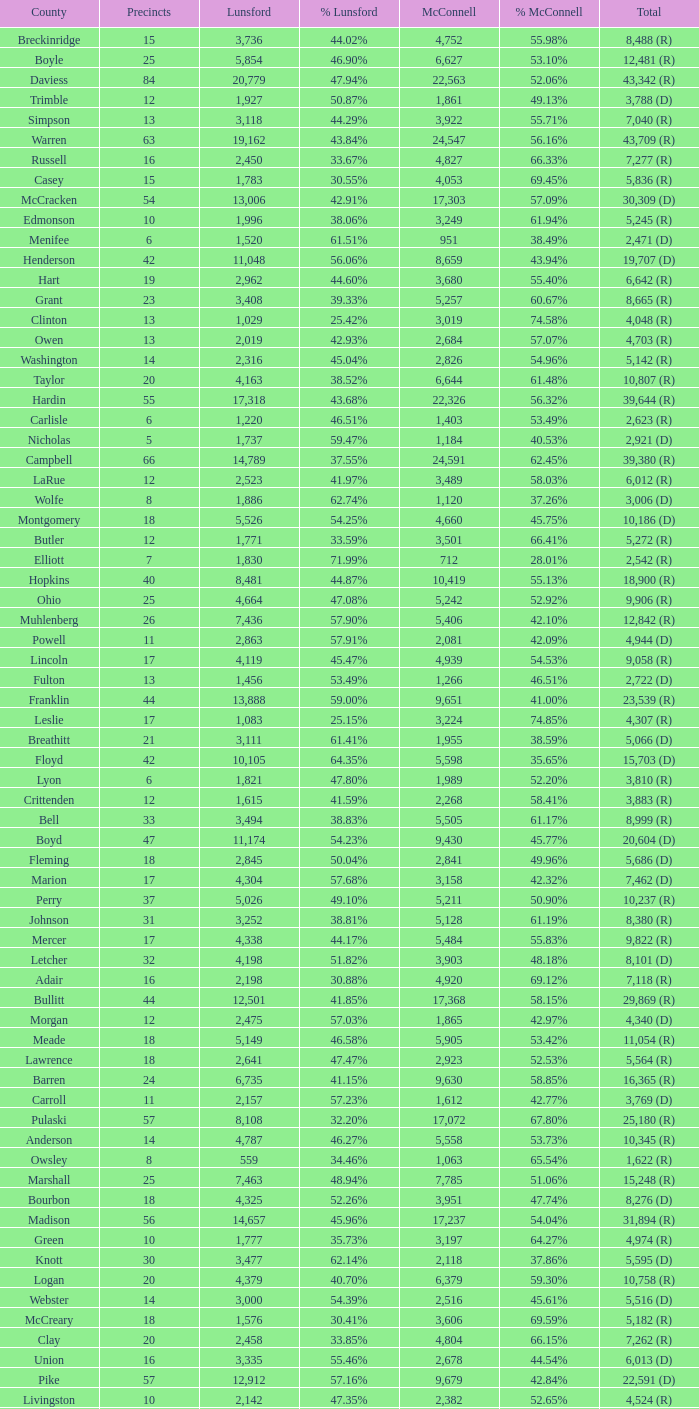What is the total number of Lunsford votes when the percentage of those votes is 33.85%? 1.0. Would you be able to parse every entry in this table? {'header': ['County', 'Precincts', 'Lunsford', '% Lunsford', 'McConnell', '% McConnell', 'Total'], 'rows': [['Breckinridge', '15', '3,736', '44.02%', '4,752', '55.98%', '8,488 (R)'], ['Boyle', '25', '5,854', '46.90%', '6,627', '53.10%', '12,481 (R)'], ['Daviess', '84', '20,779', '47.94%', '22,563', '52.06%', '43,342 (R)'], ['Trimble', '12', '1,927', '50.87%', '1,861', '49.13%', '3,788 (D)'], ['Simpson', '13', '3,118', '44.29%', '3,922', '55.71%', '7,040 (R)'], ['Warren', '63', '19,162', '43.84%', '24,547', '56.16%', '43,709 (R)'], ['Russell', '16', '2,450', '33.67%', '4,827', '66.33%', '7,277 (R)'], ['Casey', '15', '1,783', '30.55%', '4,053', '69.45%', '5,836 (R)'], ['McCracken', '54', '13,006', '42.91%', '17,303', '57.09%', '30,309 (D)'], ['Edmonson', '10', '1,996', '38.06%', '3,249', '61.94%', '5,245 (R)'], ['Menifee', '6', '1,520', '61.51%', '951', '38.49%', '2,471 (D)'], ['Henderson', '42', '11,048', '56.06%', '8,659', '43.94%', '19,707 (D)'], ['Hart', '19', '2,962', '44.60%', '3,680', '55.40%', '6,642 (R)'], ['Grant', '23', '3,408', '39.33%', '5,257', '60.67%', '8,665 (R)'], ['Clinton', '13', '1,029', '25.42%', '3,019', '74.58%', '4,048 (R)'], ['Owen', '13', '2,019', '42.93%', '2,684', '57.07%', '4,703 (R)'], ['Washington', '14', '2,316', '45.04%', '2,826', '54.96%', '5,142 (R)'], ['Taylor', '20', '4,163', '38.52%', '6,644', '61.48%', '10,807 (R)'], ['Hardin', '55', '17,318', '43.68%', '22,326', '56.32%', '39,644 (R)'], ['Carlisle', '6', '1,220', '46.51%', '1,403', '53.49%', '2,623 (R)'], ['Nicholas', '5', '1,737', '59.47%', '1,184', '40.53%', '2,921 (D)'], ['Campbell', '66', '14,789', '37.55%', '24,591', '62.45%', '39,380 (R)'], ['LaRue', '12', '2,523', '41.97%', '3,489', '58.03%', '6,012 (R)'], ['Wolfe', '8', '1,886', '62.74%', '1,120', '37.26%', '3,006 (D)'], ['Montgomery', '18', '5,526', '54.25%', '4,660', '45.75%', '10,186 (D)'], ['Butler', '12', '1,771', '33.59%', '3,501', '66.41%', '5,272 (R)'], ['Elliott', '7', '1,830', '71.99%', '712', '28.01%', '2,542 (R)'], ['Hopkins', '40', '8,481', '44.87%', '10,419', '55.13%', '18,900 (R)'], ['Ohio', '25', '4,664', '47.08%', '5,242', '52.92%', '9,906 (R)'], ['Muhlenberg', '26', '7,436', '57.90%', '5,406', '42.10%', '12,842 (R)'], ['Powell', '11', '2,863', '57.91%', '2,081', '42.09%', '4,944 (D)'], ['Lincoln', '17', '4,119', '45.47%', '4,939', '54.53%', '9,058 (R)'], ['Fulton', '13', '1,456', '53.49%', '1,266', '46.51%', '2,722 (D)'], ['Franklin', '44', '13,888', '59.00%', '9,651', '41.00%', '23,539 (R)'], ['Leslie', '17', '1,083', '25.15%', '3,224', '74.85%', '4,307 (R)'], ['Breathitt', '21', '3,111', '61.41%', '1,955', '38.59%', '5,066 (D)'], ['Floyd', '42', '10,105', '64.35%', '5,598', '35.65%', '15,703 (D)'], ['Lyon', '6', '1,821', '47.80%', '1,989', '52.20%', '3,810 (R)'], ['Crittenden', '12', '1,615', '41.59%', '2,268', '58.41%', '3,883 (R)'], ['Bell', '33', '3,494', '38.83%', '5,505', '61.17%', '8,999 (R)'], ['Boyd', '47', '11,174', '54.23%', '9,430', '45.77%', '20,604 (D)'], ['Fleming', '18', '2,845', '50.04%', '2,841', '49.96%', '5,686 (D)'], ['Marion', '17', '4,304', '57.68%', '3,158', '42.32%', '7,462 (D)'], ['Perry', '37', '5,026', '49.10%', '5,211', '50.90%', '10,237 (R)'], ['Johnson', '31', '3,252', '38.81%', '5,128', '61.19%', '8,380 (R)'], ['Mercer', '17', '4,338', '44.17%', '5,484', '55.83%', '9,822 (R)'], ['Letcher', '32', '4,198', '51.82%', '3,903', '48.18%', '8,101 (D)'], ['Adair', '16', '2,198', '30.88%', '4,920', '69.12%', '7,118 (R)'], ['Bullitt', '44', '12,501', '41.85%', '17,368', '58.15%', '29,869 (R)'], ['Morgan', '12', '2,475', '57.03%', '1,865', '42.97%', '4,340 (D)'], ['Meade', '18', '5,149', '46.58%', '5,905', '53.42%', '11,054 (R)'], ['Lawrence', '18', '2,641', '47.47%', '2,923', '52.53%', '5,564 (R)'], ['Barren', '24', '6,735', '41.15%', '9,630', '58.85%', '16,365 (R)'], ['Carroll', '11', '2,157', '57.23%', '1,612', '42.77%', '3,769 (D)'], ['Pulaski', '57', '8,108', '32.20%', '17,072', '67.80%', '25,180 (R)'], ['Anderson', '14', '4,787', '46.27%', '5,558', '53.73%', '10,345 (R)'], ['Owsley', '8', '559', '34.46%', '1,063', '65.54%', '1,622 (R)'], ['Marshall', '25', '7,463', '48.94%', '7,785', '51.06%', '15,248 (R)'], ['Bourbon', '18', '4,325', '52.26%', '3,951', '47.74%', '8,276 (D)'], ['Madison', '56', '14,657', '45.96%', '17,237', '54.04%', '31,894 (R)'], ['Green', '10', '1,777', '35.73%', '3,197', '64.27%', '4,974 (R)'], ['Knott', '30', '3,477', '62.14%', '2,118', '37.86%', '5,595 (D)'], ['Logan', '20', '4,379', '40.70%', '6,379', '59.30%', '10,758 (R)'], ['Webster', '14', '3,000', '54.39%', '2,516', '45.61%', '5,516 (D)'], ['McCreary', '18', '1,576', '30.41%', '3,606', '69.59%', '5,182 (R)'], ['Clay', '20', '2,458', '33.85%', '4,804', '66.15%', '7,262 (R)'], ['Union', '16', '3,335', '55.46%', '2,678', '44.54%', '6,013 (D)'], ['Pike', '57', '12,912', '57.16%', '9,679', '42.84%', '22,591 (D)'], ['Livingston', '10', '2,142', '47.35%', '2,382', '52.65%', '4,524 (R)'], ['Kenton', '108', '19,217', '36.26%', '33,787', '63.74%', '53,004 (R)'], ['Monroe', '12', '1,237', '27.16%', '3,318', '72.84%', '4,555 (R)'], ['Mason', '20', '3,095', '44.58%', '3,847', '55.42%', '6,942 (R)'], ['Greenup', '32', '8,258', '52.83%', '7,374', '47.17%', '15,632 (D)'], ['Woodford', '16', '5,903', '48.65%', '6,231', '51.35%', '12,134 (R)'], ['Estill', '15', '2,162', '41.36%', '3,065', '58.64%', '5,227 (R)'], ['Gallatin', '8', '1,435', '45.66%', '1,708', '54.34%', '3,143 (R)'], ['Jefferson', '515', '195,401', '55.73%', '155,241', '44.27%', '350,642 (D)'], ['Oldham', '34', '10,204', '35.25%', '18,744', '64.75%', '28,948 (R)'], ['Grayson', '23', '3,863', '39.23%', '5,983', '60.77%', '9,846 (R)'], ['Laurel', '45', '6,850', '31.15%', '15,138', '68.85%', '21,988 (R)'], ['Scott', '35', '9,238', '47.36%', '10,267', '52.64%', '19,505 (R)'], ['Martin', '14', '1,203', '33.19%', '2,422', '66.81%', '3,625 (R)'], ['Jackson', '14', '1,245', '24.71%', '3,794', '75.29%', '5,039 (R)'], ['Wayne', '19', '3,045', '43.30%', '3,987', '56.70%', '7,032 (R)'], ['Rowan', '18', '4,710', '58.71%', '3,312', '41.29%', '8,022 (D)'], ['Graves', '30', '7,839', '48.76%', '8,239', '51.24%', '16,078 (R)'], ['Magoffin', '14', '2,719', '58.81%', '1,904', '41.19%', '4,623 (D)'], ['McLean', '8', '2,225', '50.55%', '2,177', '49.45%', '4,402 (D)'], ['Lee', '10', '1,073', '39.77%', '1,625', '60.23%', '2,698 (R)'], ['Spencer', '11', '3,159', '39.64%', '4,811', '60.36%', '7,970 (R)'], ['Boone', '60', '15,224', '30.75%', '34,285', '69.25%', '49,509 (R)'], ['Shelby', '33', '7,546', '41.15%', '10,790', '58.85%', '18,336 (R)'], ['Christian', '44', '9,030', '40.79%', '13,109', '59.21%', '22,139 (R)'], ['Carter', '23', '5,220', '53.74%', '4,494', '46.26%', '9,714 (D)'], ['Garrard', '13', '2,858', '40.11%', '4,268', '59.89%', '7,126 (R)'], ['Hancock', '10', '2,298', '56.09%', '1,799', '43.91%', '4,097 (D)'], ['Knox', '30', '4,329', '39.01%', '6,767', '60.99%', '11,096 (R)'], ['Harrison', '17', '3,814', '50.47%', '3,743', '49.53%', '7,557 (D)'], ['Nelson', '26', '8,823', '49.60%', '8,965', '50.40%', '17,788 (R)'], ['Cumberland', '9', '763', '28.62%', '1,903', '71.38%', '2,666 (R)'], ['Lewis', '14', '1,787', '38.26%', '2,884', '61.74%', '4,671 (R)'], ['Jessamine', '37', '7,847', '39.60%', '11,969', '60.40%', '19,816 (R)'], ['Allen', '13', '2,331', '31.85%', '4,987', '68.15%', '7,318 (R)'], ['Clark', '26', '7,436', '48.49%', '7,898', '51.51%', '15,334 (R)'], ['Trigg', '14', '2,637', '40.76%', '3,833', '59.24%', '6,470 (R)'], ['Metcalfe', '12', '1,766', '44.03%', '2,245', '55.97%', '4,011 (R)'], ['Bath', '12', '2,747', '61.36%', '1,730', '38.64%', '4,477 (D)'], ['Hickman', '6', '1,049', '47.49%', '1,160', '52.51%', '2,209 (R)'], ['Harlan', '35', '4,440', '45.92%', '5,229', '54.08%', '9,669 (R)'], ['Rockcastle', '14', '1,837', '30.55%', '4,177', '69.45%', '6,014 (R)'], ['Ballard', '13', '1,893', '46.68%', '2,162', '53.32%', '4,055 (R)'], ['Calloway', '30', '6,870', '45.39%', '8,266', '54.61%', '15,136 (R)'], ['Robertson', '5', '498', '49.21%', '514', '50.79%', '1,012 (R)'], ['Pendleton', '12', '2,155', '37.97%', '3,520', '62.03%', '5,675 (R)'], ['Whitley', '36', '4,849', '36.37%', '8,484', '63.63%', '13,333 (R)'], ['Henry', '20', '3,194', '46.52%', '3,672', '53.48%', '6,866 (R)'], ['Caldwell', '13', '2,821', '46.30%', '3,272', '53.70%', '6,093 (R)'], ['Todd', '13', '1,772', '36.89%', '3,032', '63.11%', '4,804 (R)'], ['Fayette', '274', '68,029', '54.15%', '57,605', '45.85%', '125,634 (R)'], ['Bracken', '8', '1,382', '41.17%', '1,975', '58.83%', '3,357 (R)']]} 